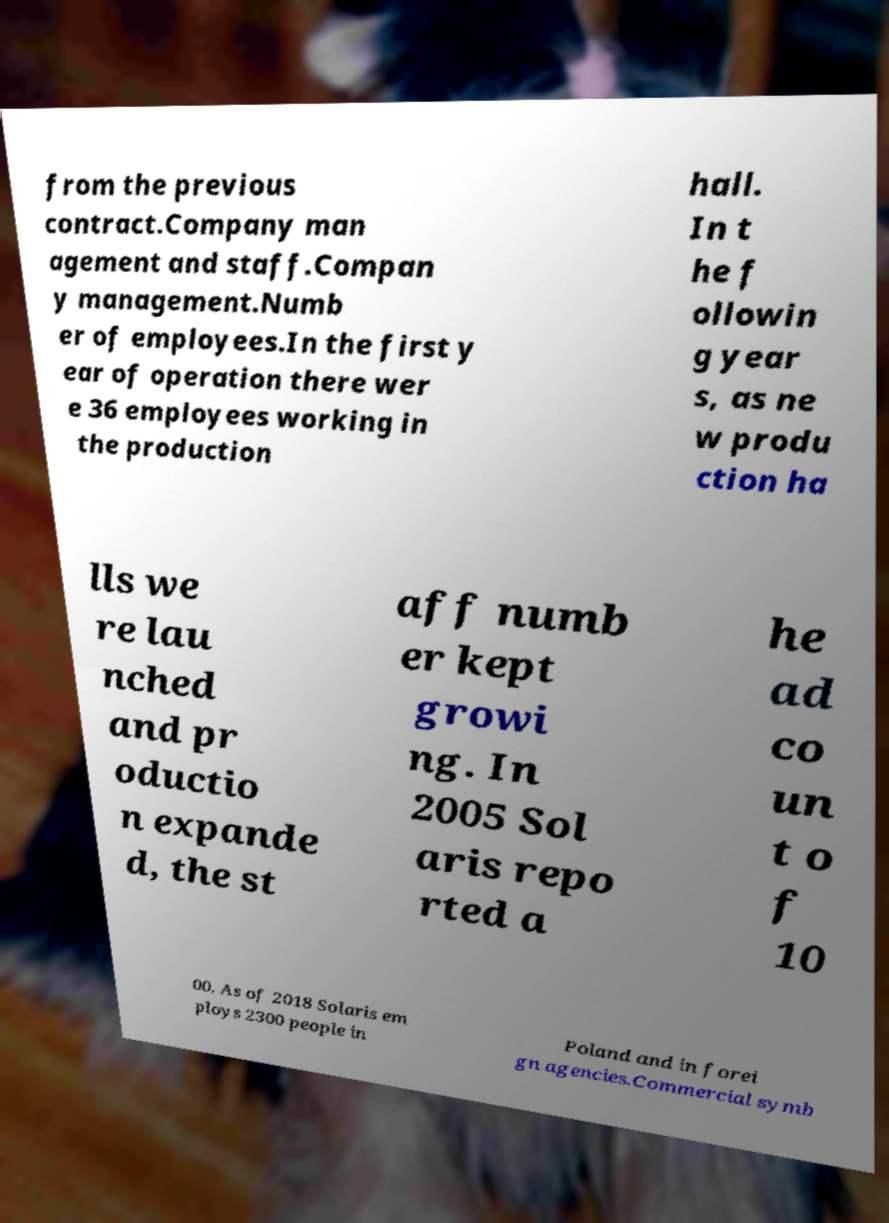Please identify and transcribe the text found in this image. from the previous contract.Company man agement and staff.Compan y management.Numb er of employees.In the first y ear of operation there wer e 36 employees working in the production hall. In t he f ollowin g year s, as ne w produ ction ha lls we re lau nched and pr oductio n expande d, the st aff numb er kept growi ng. In 2005 Sol aris repo rted a he ad co un t o f 10 00. As of 2018 Solaris em ploys 2300 people in Poland and in forei gn agencies.Commercial symb 